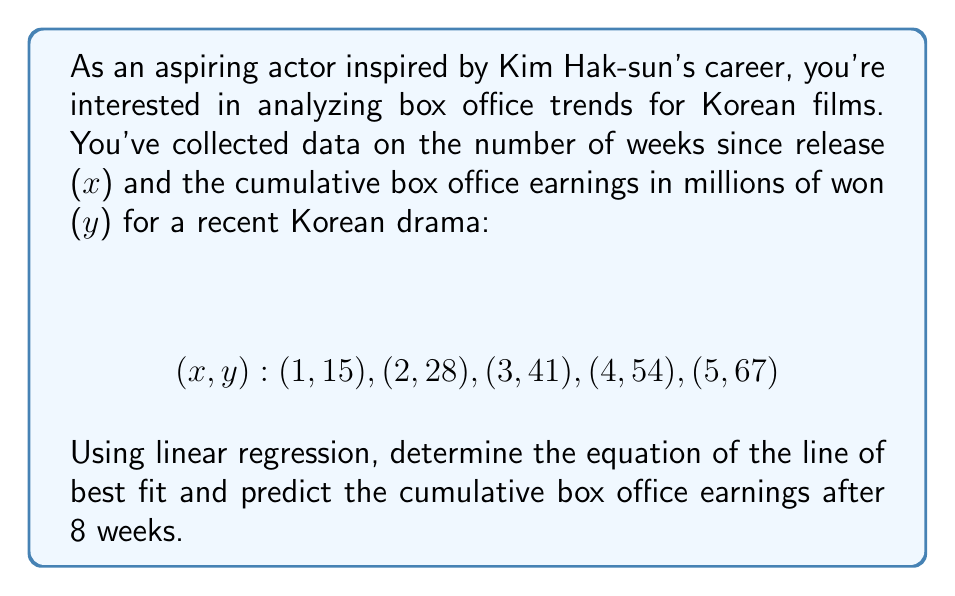Show me your answer to this math problem. To solve this problem, we'll use linear regression to find the line of best fit and then use that equation to predict future earnings.

1. Calculate the means of x and y:
   $$\bar{x} = \frac{1 + 2 + 3 + 4 + 5}{5} = 3$$
   $$\bar{y} = \frac{15 + 28 + 41 + 54 + 67}{5} = 41$$

2. Calculate the slope (m) using the formula:
   $$m = \frac{\sum(x - \bar{x})(y - \bar{y})}{\sum(x - \bar{x})^2}$$

   $$(x - \bar{x})(y - \bar{y}): (-2)(-26), (-1)(-13), (0)(0), (1)(13), (2)(26)$$
   $$\sum(x - \bar{x})(y - \bar{y}) = 52 + 13 + 0 + 13 + 52 = 130$$

   $$(x - \bar{x})^2: 4, 1, 0, 1, 4$$
   $$\sum(x - \bar{x})^2 = 10$$

   $$m = \frac{130}{10} = 13$$

3. Calculate the y-intercept (b) using the point-slope form:
   $$y - \bar{y} = m(x - \bar{x})$$
   $$41 = 13(3) + b$$
   $$b = 41 - 39 = 2$$

4. The equation of the line of best fit is:
   $$y = 13x + 2$$

5. To predict the cumulative box office earnings after 8 weeks, substitute x = 8:
   $$y = 13(8) + 2 = 104 + 2 = 106$$
Answer: The equation of the line of best fit is $y = 13x + 2$, where x is the number of weeks since release and y is the cumulative box office earnings in millions of won. The predicted cumulative box office earnings after 8 weeks is 106 million won. 